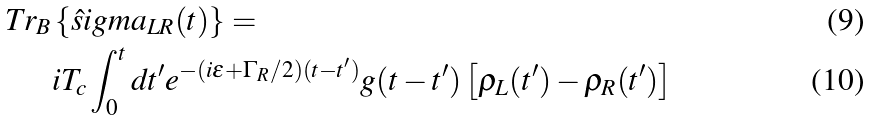Convert formula to latex. <formula><loc_0><loc_0><loc_500><loc_500>T r _ { B } & \left \{ \hat { s } i g m a _ { L R } ( t ) \right \} = \\ & i T _ { c } \int _ { 0 } ^ { t } d t ^ { \prime } e ^ { - ( i \varepsilon + \Gamma _ { R } / 2 ) ( t - t ^ { \prime } ) } g ( t - t ^ { \prime } ) \left [ \rho _ { L } ( t ^ { \prime } ) - \rho _ { R } ( t ^ { \prime } ) \right ]</formula> 